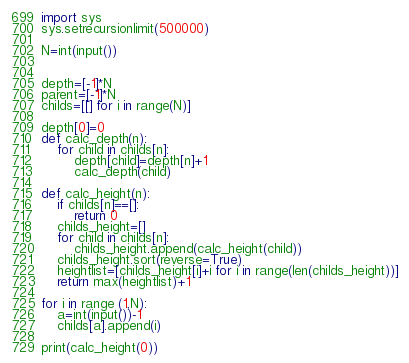<code> <loc_0><loc_0><loc_500><loc_500><_Python_>import sys
sys.setrecursionlimit(500000)

N=int(input())


depth=[-1]*N
parent=[-1]*N
childs=[[] for i in range(N)]

depth[0]=0
def calc_depth(n):
    for child in childs[n]:
        depth[child]=depth[n]+1
        calc_depth(child)

def calc_height(n):
    if childs[n]==[]:
        return 0 
    childs_height=[]
    for child in childs[n]:
        childs_height.append(calc_height(child))
    childs_height.sort(reverse=True)
    heightlist=[childs_height[i]+i for i in range(len(childs_height))]
    return max(heightlist)+1

for i in range (1,N):
    a=int(input())-1
    childs[a].append(i)

print(calc_height(0))
</code> 